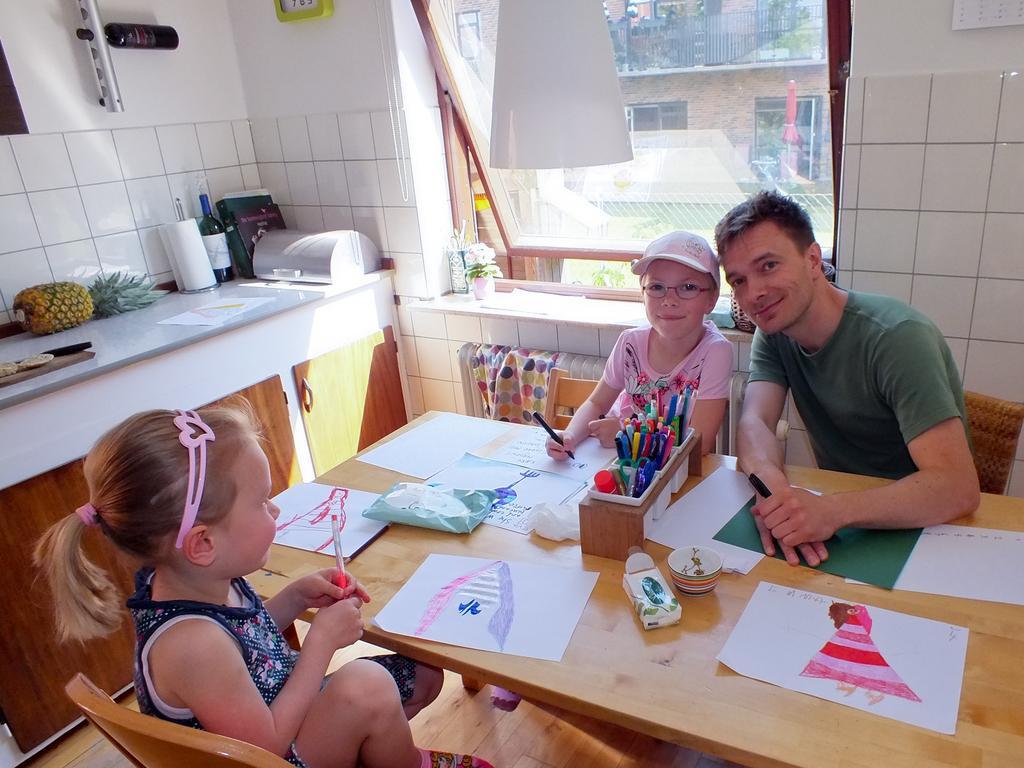Could you give a brief overview of what you see in this image? In this picture there is a man and girl sitting on the chair. There are few paintings ,bowl, pens on the table. There is a pineapple,bottle, tissue roll , knife on the table. There is a building at the background. 